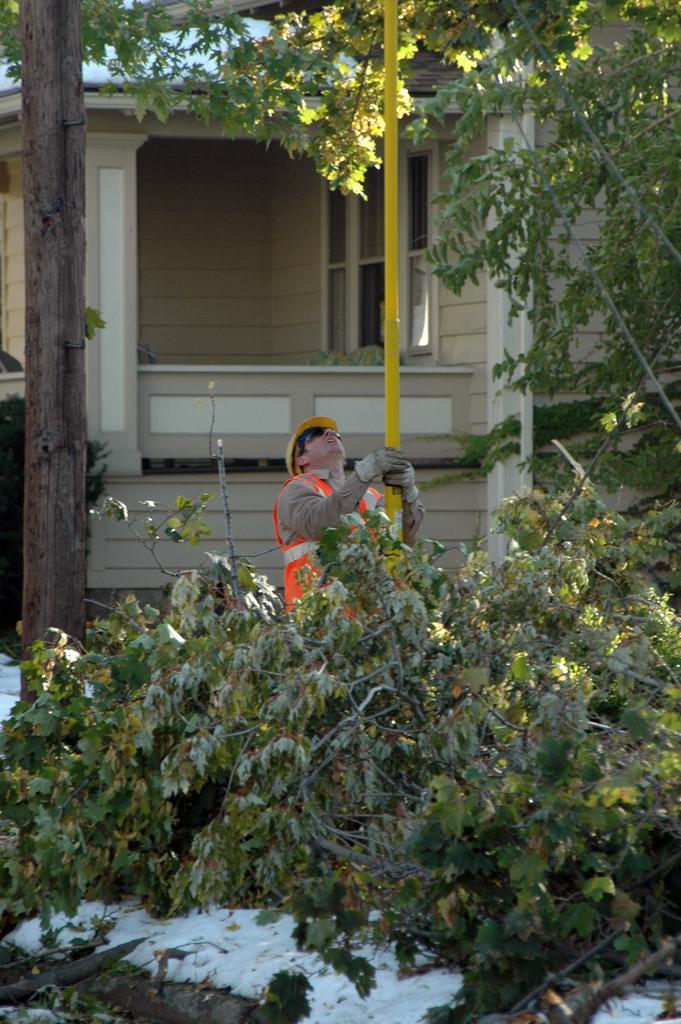How would you summarize this image in a sentence or two? There is a person wearing gloves, goggles and a cap is holding a pole. There is a tree. On the ground there are branches. In the back there is a building with windows and pillar. 